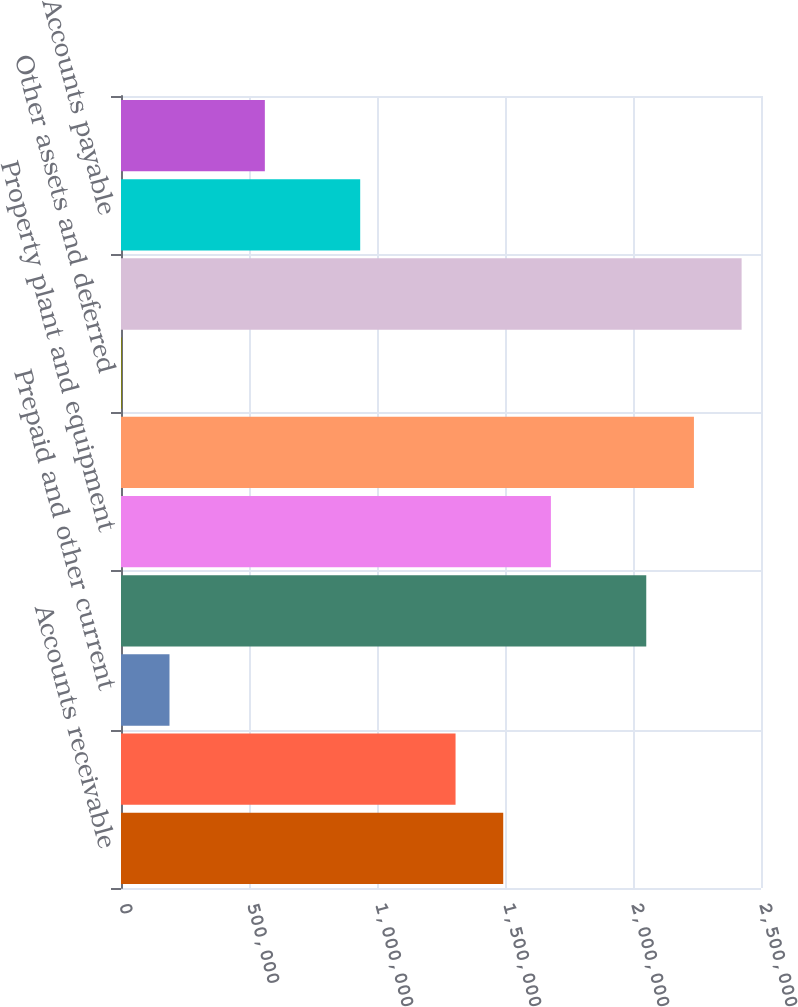Convert chart to OTSL. <chart><loc_0><loc_0><loc_500><loc_500><bar_chart><fcel>Accounts receivable<fcel>Inventories net<fcel>Prepaid and other current<fcel>Total current assets<fcel>Property plant and equipment<fcel>Goodwill and intangible assets<fcel>Other assets and deferred<fcel>Total assets<fcel>Accounts payable<fcel>Other current liabilities<nl><fcel>1.49308e+06<fcel>1.30685e+06<fcel>189435<fcel>2.05179e+06<fcel>1.67932e+06<fcel>2.23802e+06<fcel>3200<fcel>2.42426e+06<fcel>934376<fcel>561906<nl></chart> 